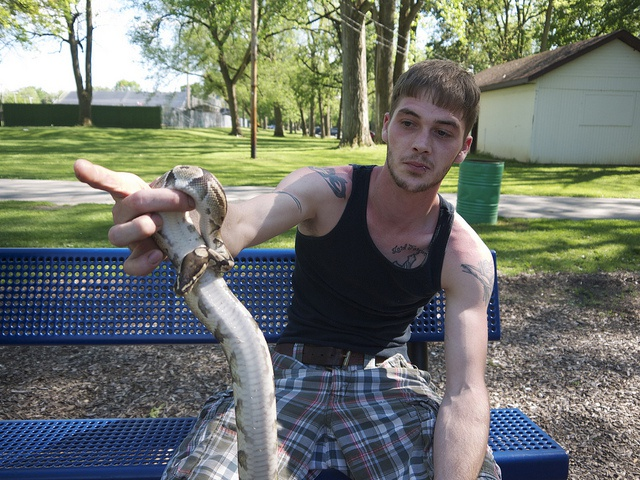Describe the objects in this image and their specific colors. I can see people in darkgreen, black, gray, darkgray, and lightgray tones and bench in darkgreen, navy, black, blue, and gray tones in this image. 